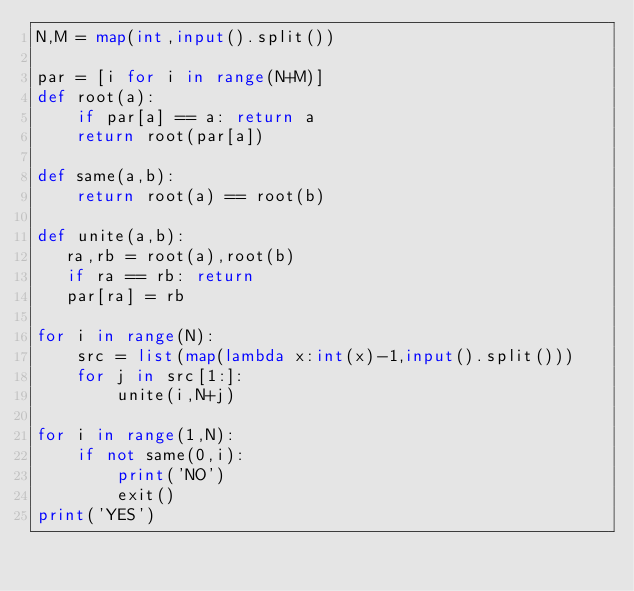Convert code to text. <code><loc_0><loc_0><loc_500><loc_500><_Python_>N,M = map(int,input().split())

par = [i for i in range(N+M)]
def root(a):
    if par[a] == a: return a
    return root(par[a])

def same(a,b):
    return root(a) == root(b)

def unite(a,b):
   ra,rb = root(a),root(b)
   if ra == rb: return
   par[ra] = rb

for i in range(N):
    src = list(map(lambda x:int(x)-1,input().split()))
    for j in src[1:]:
        unite(i,N+j)

for i in range(1,N):
    if not same(0,i):
        print('NO')
        exit()
print('YES')</code> 